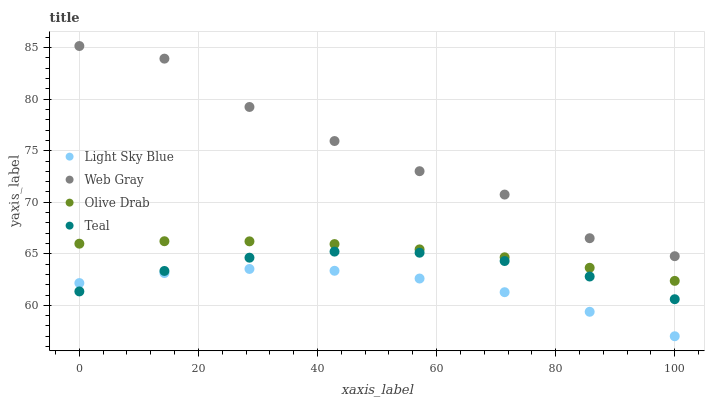Does Light Sky Blue have the minimum area under the curve?
Answer yes or no. Yes. Does Web Gray have the maximum area under the curve?
Answer yes or no. Yes. Does Teal have the minimum area under the curve?
Answer yes or no. No. Does Teal have the maximum area under the curve?
Answer yes or no. No. Is Olive Drab the smoothest?
Answer yes or no. Yes. Is Web Gray the roughest?
Answer yes or no. Yes. Is Teal the smoothest?
Answer yes or no. No. Is Teal the roughest?
Answer yes or no. No. Does Light Sky Blue have the lowest value?
Answer yes or no. Yes. Does Teal have the lowest value?
Answer yes or no. No. Does Web Gray have the highest value?
Answer yes or no. Yes. Does Teal have the highest value?
Answer yes or no. No. Is Olive Drab less than Web Gray?
Answer yes or no. Yes. Is Web Gray greater than Teal?
Answer yes or no. Yes. Does Teal intersect Light Sky Blue?
Answer yes or no. Yes. Is Teal less than Light Sky Blue?
Answer yes or no. No. Is Teal greater than Light Sky Blue?
Answer yes or no. No. Does Olive Drab intersect Web Gray?
Answer yes or no. No. 